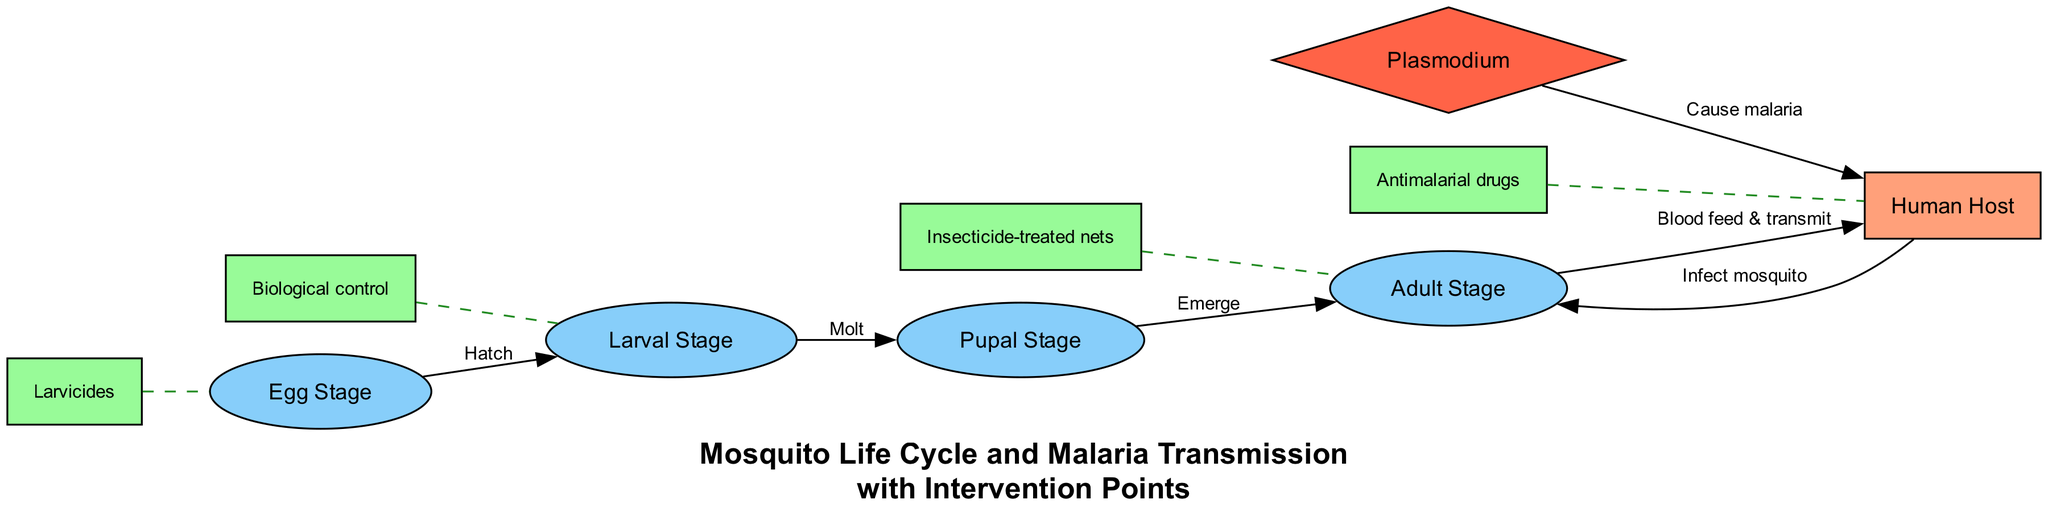What stage follows the egg stage in the life cycle of a mosquito? The diagram specifies a flow from the egg stage to the larval stage, indicated by an edge labeled "Hatch."
Answer: Larval Stage How many different stages are shown in the mosquito life cycle? By counting the nodes in the diagram, there are a total of six distinct stages: Egg Stage, Larval Stage, Pupal Stage, Adult Stage, Human Host, and Plasmodium.
Answer: Six What specific intervention method is associated with the adult stage? The diagram includes an intervention node for the adult stage labeled "Insecticide-treated nets," which directly connects to the adult stage with a dashed edge.
Answer: Insecticide-treated nets What does Plasmodium cause in humans according to the diagram? The diagram shows an edge connecting Plasmodium to human labeled "Cause malaria," establishing the relationship and consequence of being infected.
Answer: Malaria In what stage does the mosquito transition from a non-feeding state? The diagram indicates that the mosquito transitions from the pupal stage to the adult stage, where it emerges as a flying mosquito.
Answer: Pupal Stage If a human is infected, which stage is influenced, and how? The diagram indicates that when humans are infected with Plasmodium, they can infect mosquitoes, impacting the adult stage which can now transmit the malaria-causing agent.
Answer: Adult Stage What method is used to control the larval stage of mosquitoes? The diagram identifies a specific intervention for the larval stage labeled "Biological control," showing the measures taken to manage larvae development in water.
Answer: Biological control Which stage connects the adult mosquito to the human host? The diagram conveys this relationship with an edge labeled "Blood feed & transmit," indicating the adult mosquito's role in feeding on humans and transmitting malaria.
Answer: Adult Stage 